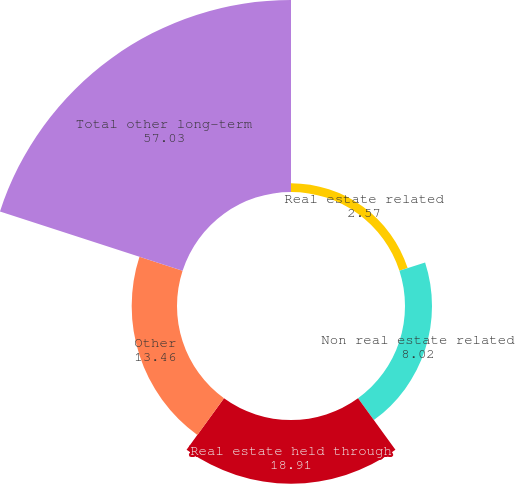Convert chart. <chart><loc_0><loc_0><loc_500><loc_500><pie_chart><fcel>Real estate related<fcel>Non real estate related<fcel>Real estate held through<fcel>Other<fcel>Total other long-term<nl><fcel>2.57%<fcel>8.02%<fcel>18.91%<fcel>13.46%<fcel>57.03%<nl></chart> 